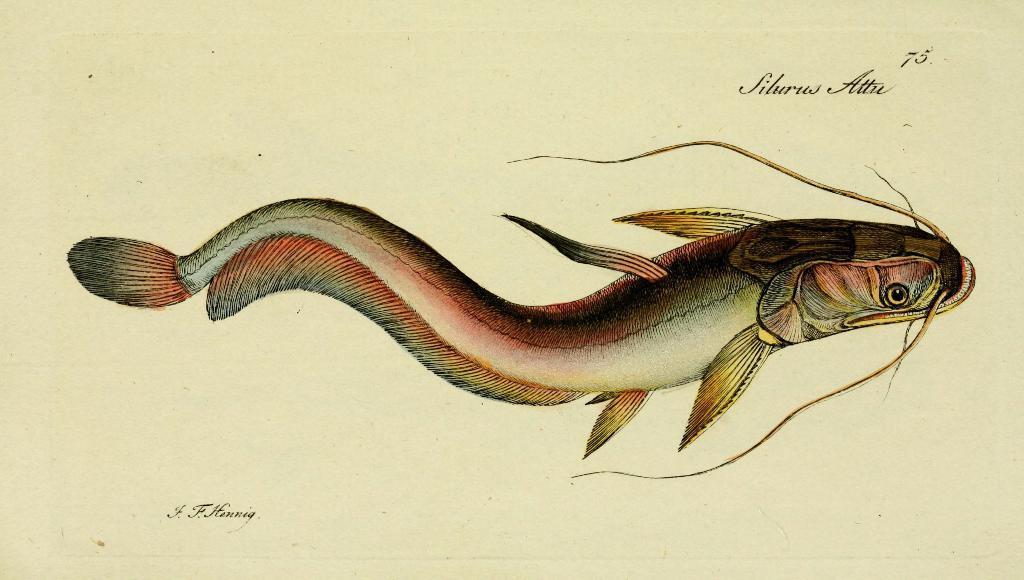Can you describe this image briefly? In this image we can see depiction of fish. 